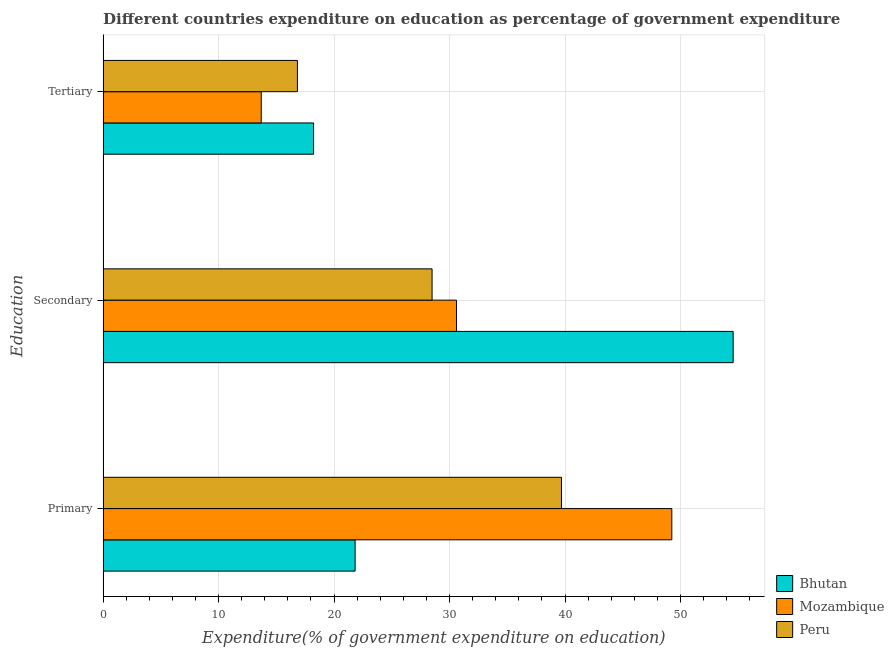How many different coloured bars are there?
Ensure brevity in your answer.  3. How many groups of bars are there?
Your answer should be compact. 3. How many bars are there on the 3rd tick from the top?
Your response must be concise. 3. How many bars are there on the 1st tick from the bottom?
Ensure brevity in your answer.  3. What is the label of the 3rd group of bars from the top?
Ensure brevity in your answer.  Primary. What is the expenditure on secondary education in Bhutan?
Give a very brief answer. 54.56. Across all countries, what is the maximum expenditure on primary education?
Your response must be concise. 49.25. Across all countries, what is the minimum expenditure on secondary education?
Make the answer very short. 28.49. In which country was the expenditure on primary education maximum?
Your answer should be very brief. Mozambique. In which country was the expenditure on primary education minimum?
Your response must be concise. Bhutan. What is the total expenditure on tertiary education in the graph?
Make the answer very short. 48.74. What is the difference between the expenditure on secondary education in Peru and that in Bhutan?
Keep it short and to the point. -26.07. What is the difference between the expenditure on tertiary education in Bhutan and the expenditure on primary education in Peru?
Ensure brevity in your answer.  -21.47. What is the average expenditure on secondary education per country?
Ensure brevity in your answer.  37.88. What is the difference between the expenditure on secondary education and expenditure on tertiary education in Mozambique?
Give a very brief answer. 16.91. What is the ratio of the expenditure on secondary education in Peru to that in Mozambique?
Your answer should be very brief. 0.93. Is the expenditure on secondary education in Mozambique less than that in Peru?
Give a very brief answer. No. Is the difference between the expenditure on secondary education in Peru and Mozambique greater than the difference between the expenditure on primary education in Peru and Mozambique?
Give a very brief answer. Yes. What is the difference between the highest and the second highest expenditure on secondary education?
Offer a very short reply. 23.95. What is the difference between the highest and the lowest expenditure on primary education?
Your answer should be compact. 27.43. In how many countries, is the expenditure on secondary education greater than the average expenditure on secondary education taken over all countries?
Your response must be concise. 1. Is the sum of the expenditure on primary education in Bhutan and Mozambique greater than the maximum expenditure on tertiary education across all countries?
Offer a very short reply. Yes. What does the 3rd bar from the top in Secondary represents?
Offer a terse response. Bhutan. What does the 1st bar from the bottom in Primary represents?
Offer a terse response. Bhutan. Are all the bars in the graph horizontal?
Ensure brevity in your answer.  Yes. What is the difference between two consecutive major ticks on the X-axis?
Ensure brevity in your answer.  10. Does the graph contain any zero values?
Ensure brevity in your answer.  No. Where does the legend appear in the graph?
Your answer should be very brief. Bottom right. What is the title of the graph?
Your response must be concise. Different countries expenditure on education as percentage of government expenditure. What is the label or title of the X-axis?
Keep it short and to the point. Expenditure(% of government expenditure on education). What is the label or title of the Y-axis?
Provide a short and direct response. Education. What is the Expenditure(% of government expenditure on education) in Bhutan in Primary?
Ensure brevity in your answer.  21.82. What is the Expenditure(% of government expenditure on education) of Mozambique in Primary?
Offer a terse response. 49.25. What is the Expenditure(% of government expenditure on education) of Peru in Primary?
Provide a short and direct response. 39.69. What is the Expenditure(% of government expenditure on education) of Bhutan in Secondary?
Offer a very short reply. 54.56. What is the Expenditure(% of government expenditure on education) in Mozambique in Secondary?
Offer a very short reply. 30.6. What is the Expenditure(% of government expenditure on education) in Peru in Secondary?
Provide a succinct answer. 28.49. What is the Expenditure(% of government expenditure on education) of Bhutan in Tertiary?
Offer a terse response. 18.23. What is the Expenditure(% of government expenditure on education) of Mozambique in Tertiary?
Your answer should be very brief. 13.69. What is the Expenditure(% of government expenditure on education) in Peru in Tertiary?
Your answer should be compact. 16.82. Across all Education, what is the maximum Expenditure(% of government expenditure on education) in Bhutan?
Provide a succinct answer. 54.56. Across all Education, what is the maximum Expenditure(% of government expenditure on education) of Mozambique?
Make the answer very short. 49.25. Across all Education, what is the maximum Expenditure(% of government expenditure on education) in Peru?
Provide a short and direct response. 39.69. Across all Education, what is the minimum Expenditure(% of government expenditure on education) in Bhutan?
Keep it short and to the point. 18.23. Across all Education, what is the minimum Expenditure(% of government expenditure on education) of Mozambique?
Your answer should be very brief. 13.69. Across all Education, what is the minimum Expenditure(% of government expenditure on education) of Peru?
Offer a very short reply. 16.82. What is the total Expenditure(% of government expenditure on education) in Bhutan in the graph?
Make the answer very short. 94.6. What is the total Expenditure(% of government expenditure on education) of Mozambique in the graph?
Your response must be concise. 93.54. What is the total Expenditure(% of government expenditure on education) of Peru in the graph?
Ensure brevity in your answer.  85. What is the difference between the Expenditure(% of government expenditure on education) of Bhutan in Primary and that in Secondary?
Your answer should be compact. -32.74. What is the difference between the Expenditure(% of government expenditure on education) of Mozambique in Primary and that in Secondary?
Your response must be concise. 18.64. What is the difference between the Expenditure(% of government expenditure on education) of Peru in Primary and that in Secondary?
Provide a succinct answer. 11.2. What is the difference between the Expenditure(% of government expenditure on education) in Bhutan in Primary and that in Tertiary?
Provide a succinct answer. 3.6. What is the difference between the Expenditure(% of government expenditure on education) in Mozambique in Primary and that in Tertiary?
Give a very brief answer. 35.56. What is the difference between the Expenditure(% of government expenditure on education) in Peru in Primary and that in Tertiary?
Make the answer very short. 22.87. What is the difference between the Expenditure(% of government expenditure on education) of Bhutan in Secondary and that in Tertiary?
Offer a very short reply. 36.33. What is the difference between the Expenditure(% of government expenditure on education) of Mozambique in Secondary and that in Tertiary?
Ensure brevity in your answer.  16.91. What is the difference between the Expenditure(% of government expenditure on education) in Peru in Secondary and that in Tertiary?
Provide a succinct answer. 11.66. What is the difference between the Expenditure(% of government expenditure on education) of Bhutan in Primary and the Expenditure(% of government expenditure on education) of Mozambique in Secondary?
Ensure brevity in your answer.  -8.78. What is the difference between the Expenditure(% of government expenditure on education) in Bhutan in Primary and the Expenditure(% of government expenditure on education) in Peru in Secondary?
Offer a very short reply. -6.67. What is the difference between the Expenditure(% of government expenditure on education) of Mozambique in Primary and the Expenditure(% of government expenditure on education) of Peru in Secondary?
Your response must be concise. 20.76. What is the difference between the Expenditure(% of government expenditure on education) in Bhutan in Primary and the Expenditure(% of government expenditure on education) in Mozambique in Tertiary?
Provide a short and direct response. 8.13. What is the difference between the Expenditure(% of government expenditure on education) of Bhutan in Primary and the Expenditure(% of government expenditure on education) of Peru in Tertiary?
Make the answer very short. 5. What is the difference between the Expenditure(% of government expenditure on education) in Mozambique in Primary and the Expenditure(% of government expenditure on education) in Peru in Tertiary?
Offer a terse response. 32.42. What is the difference between the Expenditure(% of government expenditure on education) of Bhutan in Secondary and the Expenditure(% of government expenditure on education) of Mozambique in Tertiary?
Your response must be concise. 40.87. What is the difference between the Expenditure(% of government expenditure on education) of Bhutan in Secondary and the Expenditure(% of government expenditure on education) of Peru in Tertiary?
Provide a succinct answer. 37.73. What is the difference between the Expenditure(% of government expenditure on education) of Mozambique in Secondary and the Expenditure(% of government expenditure on education) of Peru in Tertiary?
Your answer should be very brief. 13.78. What is the average Expenditure(% of government expenditure on education) of Bhutan per Education?
Offer a terse response. 31.53. What is the average Expenditure(% of government expenditure on education) of Mozambique per Education?
Offer a terse response. 31.18. What is the average Expenditure(% of government expenditure on education) in Peru per Education?
Make the answer very short. 28.33. What is the difference between the Expenditure(% of government expenditure on education) in Bhutan and Expenditure(% of government expenditure on education) in Mozambique in Primary?
Your answer should be compact. -27.43. What is the difference between the Expenditure(% of government expenditure on education) in Bhutan and Expenditure(% of government expenditure on education) in Peru in Primary?
Give a very brief answer. -17.87. What is the difference between the Expenditure(% of government expenditure on education) of Mozambique and Expenditure(% of government expenditure on education) of Peru in Primary?
Keep it short and to the point. 9.56. What is the difference between the Expenditure(% of government expenditure on education) of Bhutan and Expenditure(% of government expenditure on education) of Mozambique in Secondary?
Keep it short and to the point. 23.95. What is the difference between the Expenditure(% of government expenditure on education) in Bhutan and Expenditure(% of government expenditure on education) in Peru in Secondary?
Provide a succinct answer. 26.07. What is the difference between the Expenditure(% of government expenditure on education) of Mozambique and Expenditure(% of government expenditure on education) of Peru in Secondary?
Your response must be concise. 2.12. What is the difference between the Expenditure(% of government expenditure on education) in Bhutan and Expenditure(% of government expenditure on education) in Mozambique in Tertiary?
Provide a short and direct response. 4.53. What is the difference between the Expenditure(% of government expenditure on education) of Bhutan and Expenditure(% of government expenditure on education) of Peru in Tertiary?
Your response must be concise. 1.4. What is the difference between the Expenditure(% of government expenditure on education) in Mozambique and Expenditure(% of government expenditure on education) in Peru in Tertiary?
Your response must be concise. -3.13. What is the ratio of the Expenditure(% of government expenditure on education) in Bhutan in Primary to that in Secondary?
Make the answer very short. 0.4. What is the ratio of the Expenditure(% of government expenditure on education) in Mozambique in Primary to that in Secondary?
Offer a terse response. 1.61. What is the ratio of the Expenditure(% of government expenditure on education) of Peru in Primary to that in Secondary?
Your response must be concise. 1.39. What is the ratio of the Expenditure(% of government expenditure on education) in Bhutan in Primary to that in Tertiary?
Make the answer very short. 1.2. What is the ratio of the Expenditure(% of government expenditure on education) in Mozambique in Primary to that in Tertiary?
Your response must be concise. 3.6. What is the ratio of the Expenditure(% of government expenditure on education) of Peru in Primary to that in Tertiary?
Provide a succinct answer. 2.36. What is the ratio of the Expenditure(% of government expenditure on education) of Bhutan in Secondary to that in Tertiary?
Ensure brevity in your answer.  2.99. What is the ratio of the Expenditure(% of government expenditure on education) in Mozambique in Secondary to that in Tertiary?
Your answer should be very brief. 2.24. What is the ratio of the Expenditure(% of government expenditure on education) in Peru in Secondary to that in Tertiary?
Offer a terse response. 1.69. What is the difference between the highest and the second highest Expenditure(% of government expenditure on education) of Bhutan?
Offer a very short reply. 32.74. What is the difference between the highest and the second highest Expenditure(% of government expenditure on education) of Mozambique?
Offer a very short reply. 18.64. What is the difference between the highest and the second highest Expenditure(% of government expenditure on education) of Peru?
Keep it short and to the point. 11.2. What is the difference between the highest and the lowest Expenditure(% of government expenditure on education) of Bhutan?
Ensure brevity in your answer.  36.33. What is the difference between the highest and the lowest Expenditure(% of government expenditure on education) in Mozambique?
Your answer should be very brief. 35.56. What is the difference between the highest and the lowest Expenditure(% of government expenditure on education) of Peru?
Make the answer very short. 22.87. 